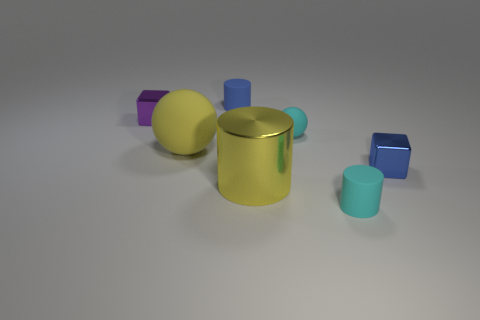There is a tiny object left of the tiny blue matte cylinder; does it have the same shape as the small blue thing in front of the cyan ball?
Your answer should be very brief. Yes. How many metal objects are both behind the yellow shiny object and on the left side of the small matte sphere?
Provide a short and direct response. 1. Are there any tiny objects that have the same color as the tiny rubber ball?
Offer a very short reply. Yes. What is the shape of the other thing that is the same size as the yellow metallic object?
Ensure brevity in your answer.  Sphere. There is a yellow metallic object; are there any yellow objects left of it?
Offer a terse response. Yes. Are the blue thing on the left side of the big yellow shiny object and the big thing on the right side of the big sphere made of the same material?
Make the answer very short. No. What number of shiny cylinders are the same size as the yellow rubber object?
Offer a terse response. 1. There is a rubber object that is the same color as the large shiny thing; what is its shape?
Your response must be concise. Sphere. What is the material of the tiny object that is left of the yellow rubber thing?
Offer a very short reply. Metal. What number of cyan things are the same shape as the large yellow rubber thing?
Offer a very short reply. 1. 